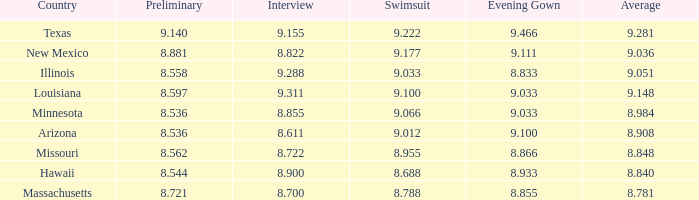What was the bathing suit score for the country having a mean score of 8.955. 